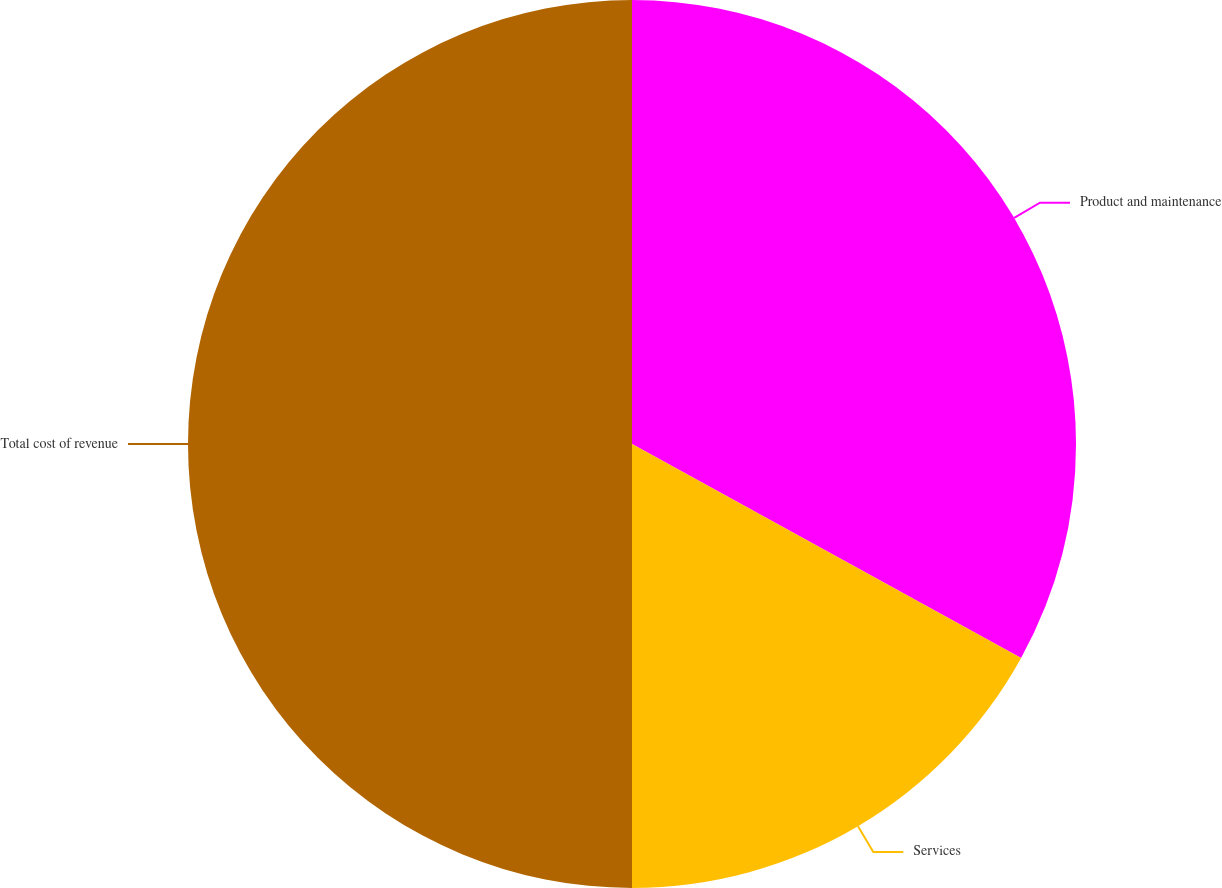Convert chart. <chart><loc_0><loc_0><loc_500><loc_500><pie_chart><fcel>Product and maintenance<fcel>Services<fcel>Total cost of revenue<nl><fcel>33.0%<fcel>17.0%<fcel>50.0%<nl></chart> 